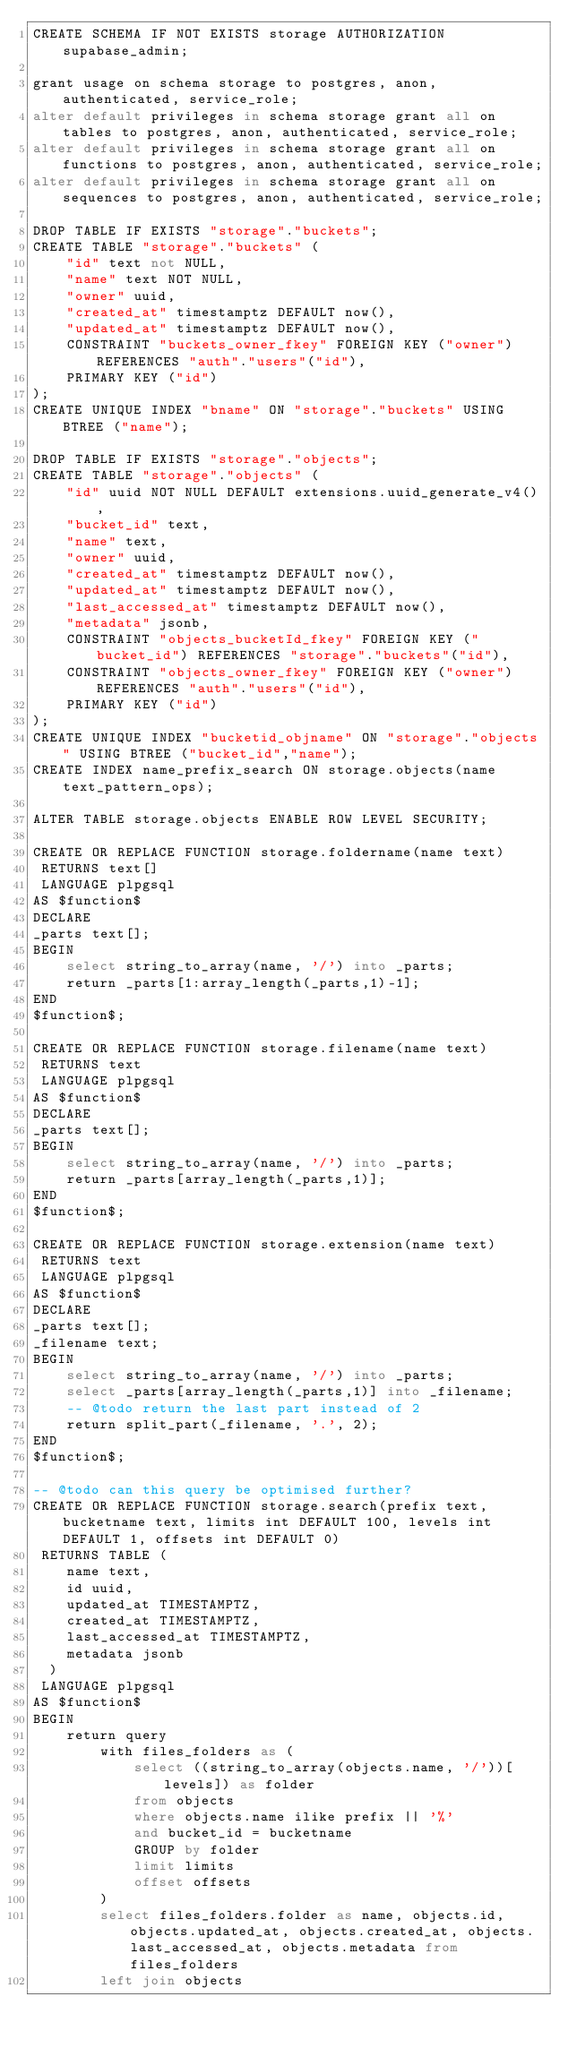<code> <loc_0><loc_0><loc_500><loc_500><_SQL_>CREATE SCHEMA IF NOT EXISTS storage AUTHORIZATION supabase_admin;

grant usage on schema storage to postgres, anon, authenticated, service_role;
alter default privileges in schema storage grant all on tables to postgres, anon, authenticated, service_role;
alter default privileges in schema storage grant all on functions to postgres, anon, authenticated, service_role;
alter default privileges in schema storage grant all on sequences to postgres, anon, authenticated, service_role;

DROP TABLE IF EXISTS "storage"."buckets";
CREATE TABLE "storage"."buckets" (
    "id" text not NULL,
    "name" text NOT NULL,
    "owner" uuid,
    "created_at" timestamptz DEFAULT now(),
    "updated_at" timestamptz DEFAULT now(),
    CONSTRAINT "buckets_owner_fkey" FOREIGN KEY ("owner") REFERENCES "auth"."users"("id"),
    PRIMARY KEY ("id")
);
CREATE UNIQUE INDEX "bname" ON "storage"."buckets" USING BTREE ("name");

DROP TABLE IF EXISTS "storage"."objects";
CREATE TABLE "storage"."objects" (
    "id" uuid NOT NULL DEFAULT extensions.uuid_generate_v4(),
    "bucket_id" text,
    "name" text,
    "owner" uuid,
    "created_at" timestamptz DEFAULT now(),
    "updated_at" timestamptz DEFAULT now(),
    "last_accessed_at" timestamptz DEFAULT now(),
    "metadata" jsonb,
    CONSTRAINT "objects_bucketId_fkey" FOREIGN KEY ("bucket_id") REFERENCES "storage"."buckets"("id"),
    CONSTRAINT "objects_owner_fkey" FOREIGN KEY ("owner") REFERENCES "auth"."users"("id"),
    PRIMARY KEY ("id")
);
CREATE UNIQUE INDEX "bucketid_objname" ON "storage"."objects" USING BTREE ("bucket_id","name");
CREATE INDEX name_prefix_search ON storage.objects(name text_pattern_ops);

ALTER TABLE storage.objects ENABLE ROW LEVEL SECURITY;

CREATE OR REPLACE FUNCTION storage.foldername(name text)
 RETURNS text[]
 LANGUAGE plpgsql
AS $function$
DECLARE
_parts text[];
BEGIN
	select string_to_array(name, '/') into _parts;
	return _parts[1:array_length(_parts,1)-1];
END
$function$;

CREATE OR REPLACE FUNCTION storage.filename(name text)
 RETURNS text
 LANGUAGE plpgsql
AS $function$
DECLARE
_parts text[];
BEGIN
	select string_to_array(name, '/') into _parts;
	return _parts[array_length(_parts,1)];
END
$function$;

CREATE OR REPLACE FUNCTION storage.extension(name text)
 RETURNS text
 LANGUAGE plpgsql
AS $function$
DECLARE
_parts text[];
_filename text;
BEGIN
	select string_to_array(name, '/') into _parts;
	select _parts[array_length(_parts,1)] into _filename;
	-- @todo return the last part instead of 2
	return split_part(_filename, '.', 2);
END
$function$;

-- @todo can this query be optimised further?
CREATE OR REPLACE FUNCTION storage.search(prefix text, bucketname text, limits int DEFAULT 100, levels int DEFAULT 1, offsets int DEFAULT 0)
 RETURNS TABLE (
    name text,
    id uuid,
    updated_at TIMESTAMPTZ,
    created_at TIMESTAMPTZ,
    last_accessed_at TIMESTAMPTZ,
    metadata jsonb
  )
 LANGUAGE plpgsql
AS $function$
BEGIN
	return query 
		with files_folders as (
			select ((string_to_array(objects.name, '/'))[levels]) as folder
			from objects
			where objects.name ilike prefix || '%'
			and bucket_id = bucketname
			GROUP by folder
			limit limits
			offset offsets
		) 
		select files_folders.folder as name, objects.id, objects.updated_at, objects.created_at, objects.last_accessed_at, objects.metadata from files_folders 
		left join objects</code> 